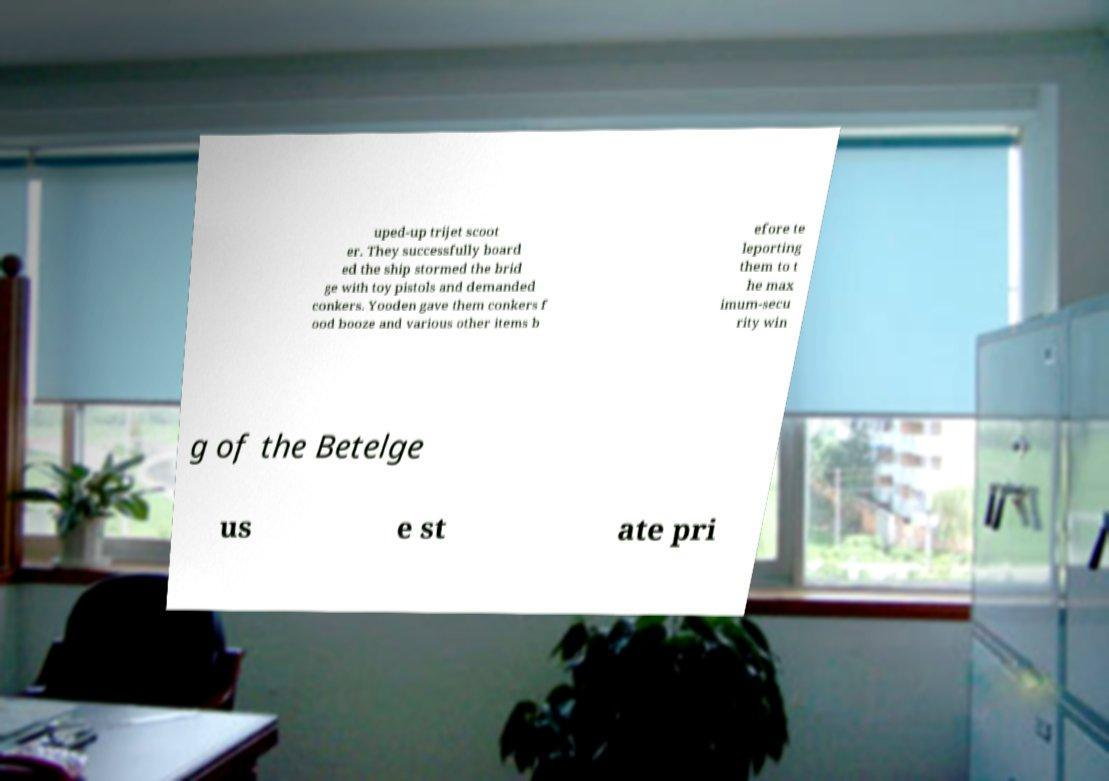Please identify and transcribe the text found in this image. uped-up trijet scoot er. They successfully board ed the ship stormed the brid ge with toy pistols and demanded conkers. Yooden gave them conkers f ood booze and various other items b efore te leporting them to t he max imum-secu rity win g of the Betelge us e st ate pri 